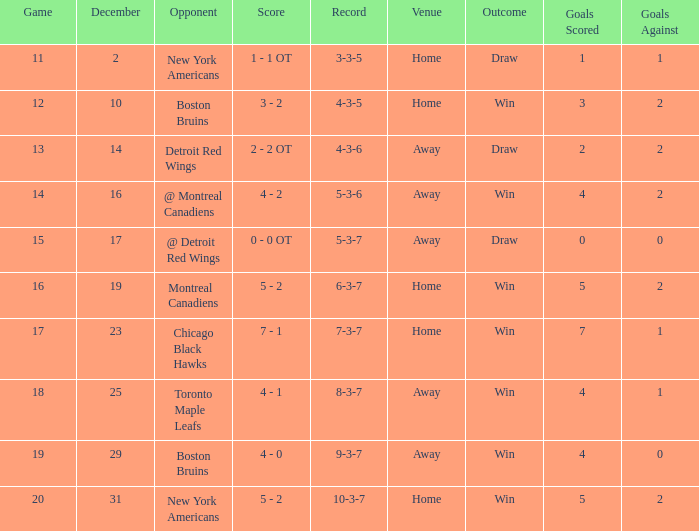Which Game is the highest one that has a Record of 4-3-6? 13.0. 